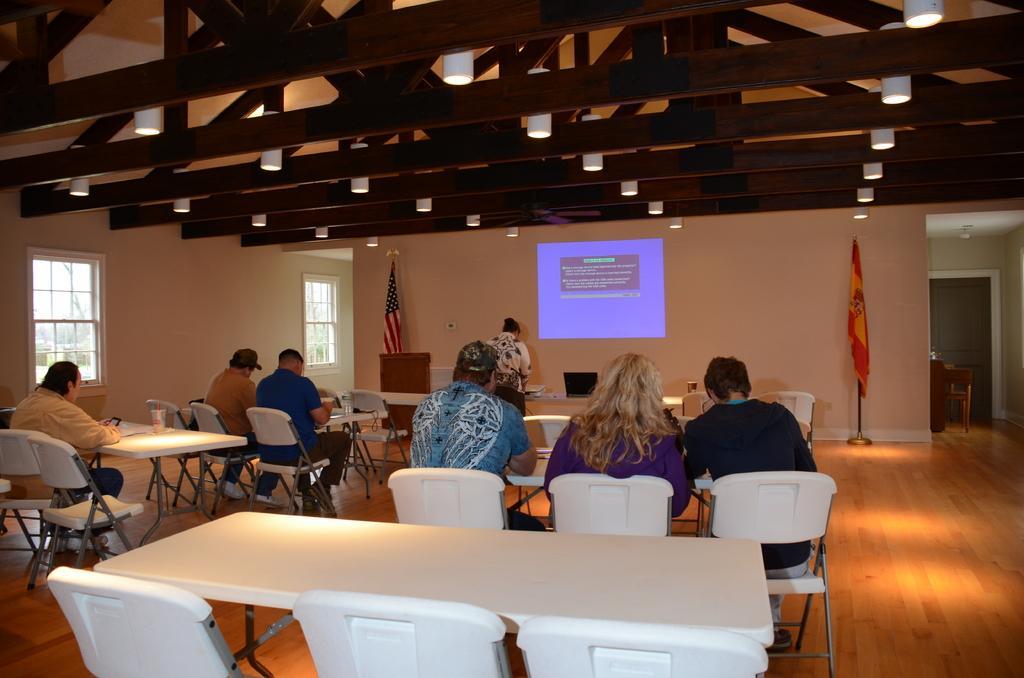Can you describe this image briefly? On top there are lights. On wall there is a screen. Far there are two flags. We can able to see chairs and tables. On chairs persons are sitting. This is window. 